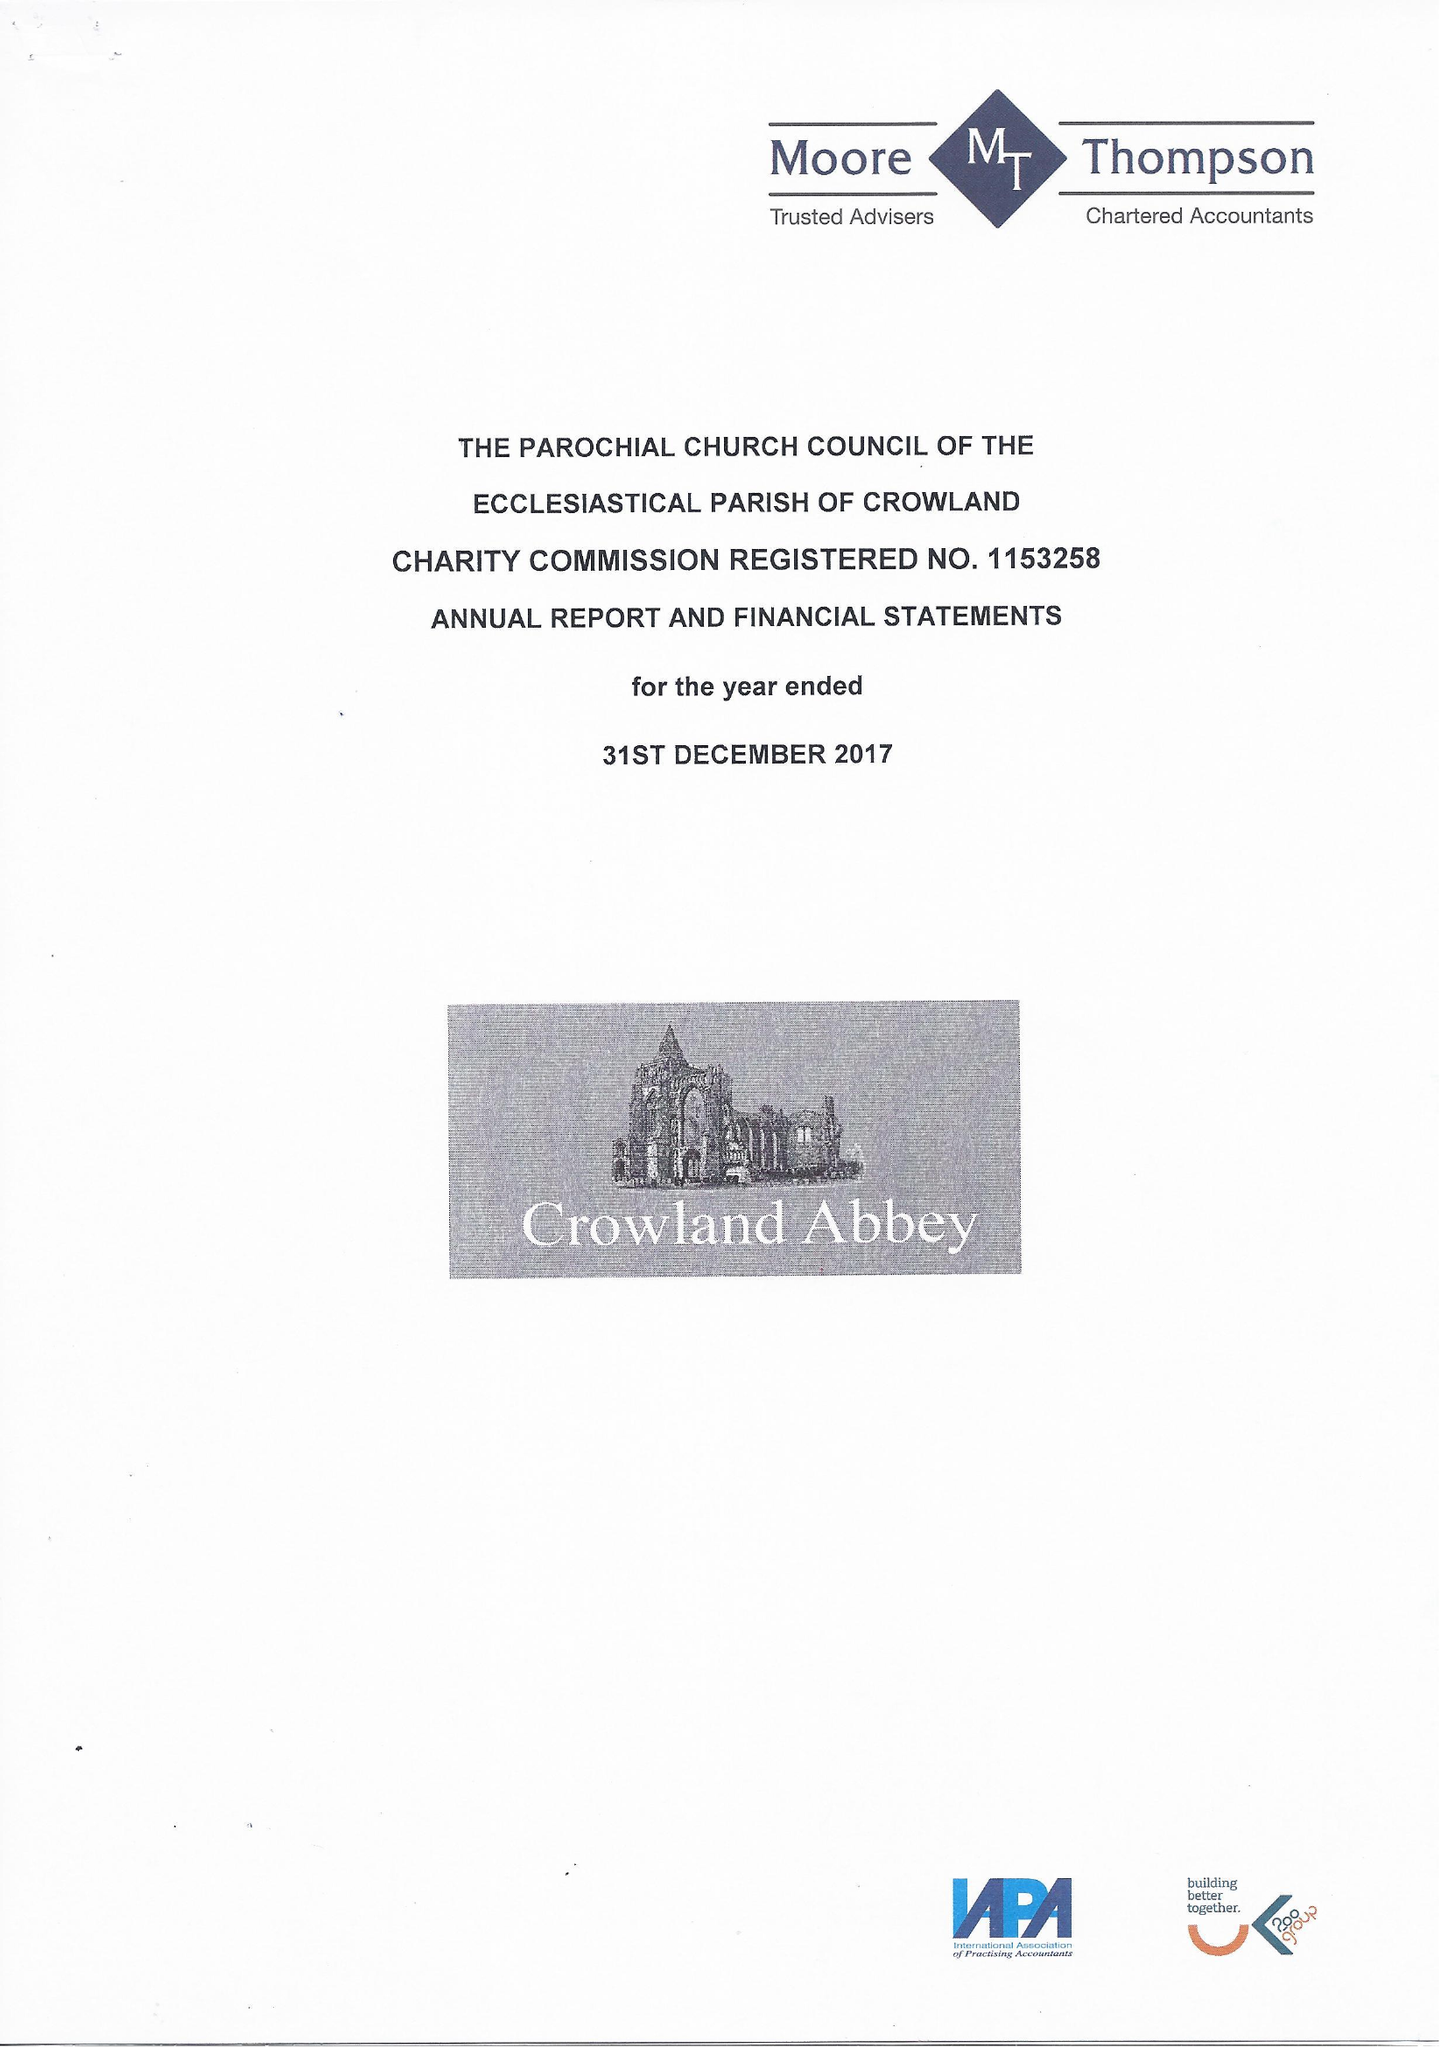What is the value for the address__postcode?
Answer the question using a single word or phrase. PE6 0AQ 